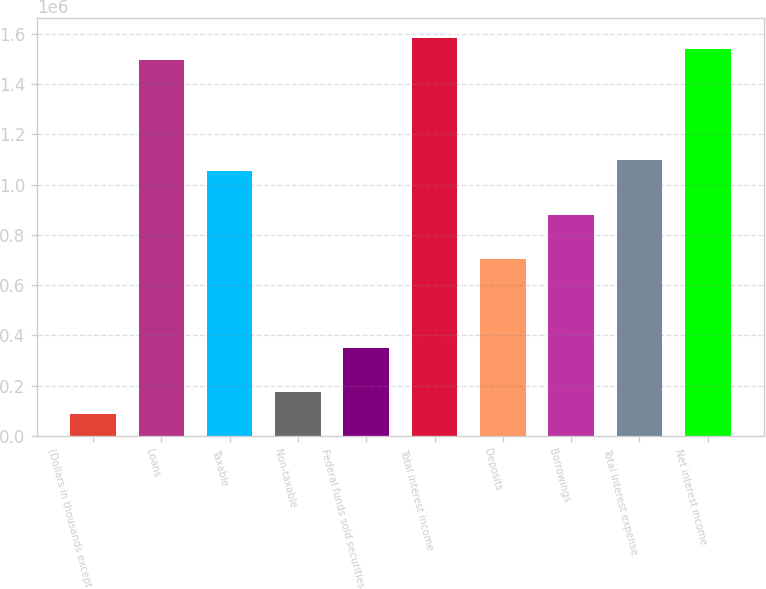<chart> <loc_0><loc_0><loc_500><loc_500><bar_chart><fcel>(Dollars in thousands except<fcel>Loans<fcel>Taxable<fcel>Non-taxable<fcel>Federal funds sold securities<fcel>Total interest income<fcel>Deposits<fcel>Borrowings<fcel>Total interest expense<fcel>Net interest income<nl><fcel>87899.9<fcel>1.49426e+06<fcel>1.05478e+06<fcel>175798<fcel>351593<fcel>1.58216e+06<fcel>703184<fcel>878980<fcel>1.09872e+06<fcel>1.53821e+06<nl></chart> 